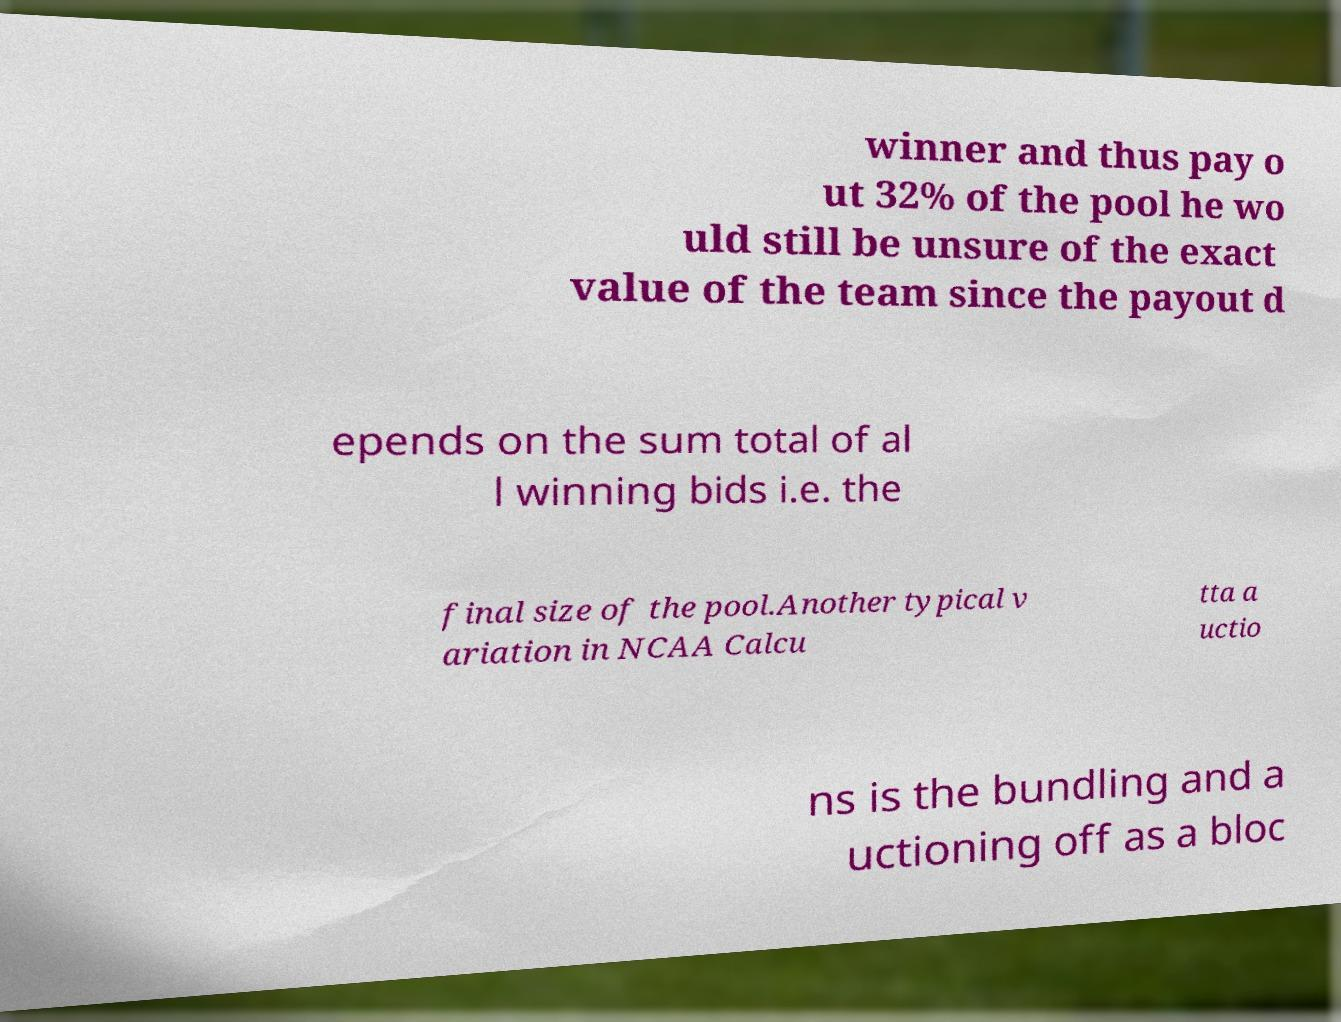Could you assist in decoding the text presented in this image and type it out clearly? winner and thus pay o ut 32% of the pool he wo uld still be unsure of the exact value of the team since the payout d epends on the sum total of al l winning bids i.e. the final size of the pool.Another typical v ariation in NCAA Calcu tta a uctio ns is the bundling and a uctioning off as a bloc 